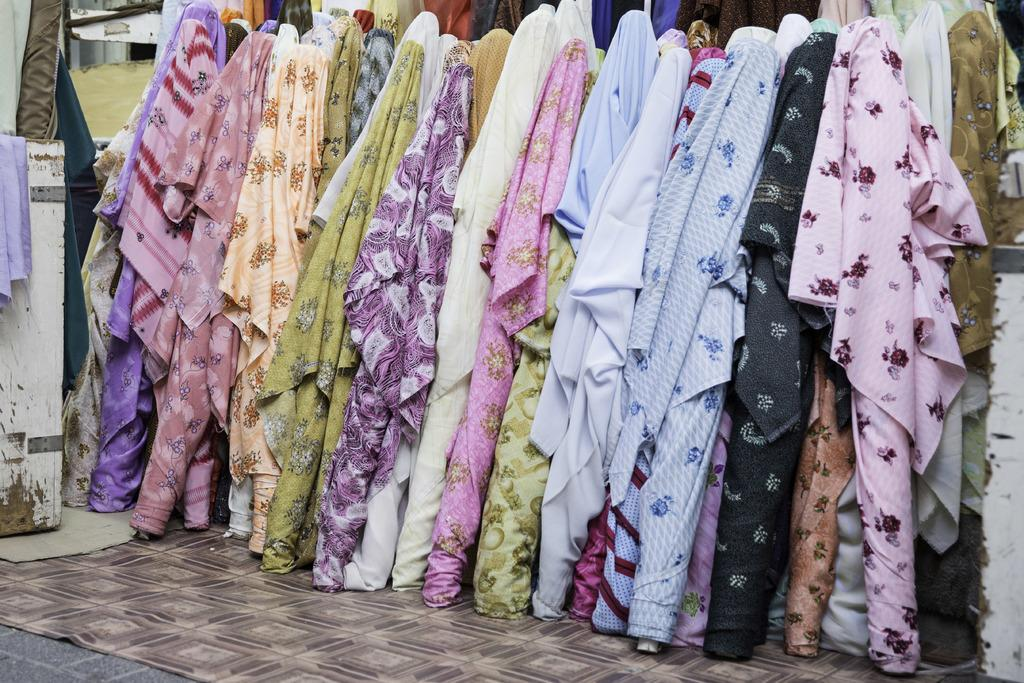What type of items are visible in the image? There are clothes in multi colors in the image. What is the color of the background wall in the image? The background wall is white in color. How many girls are present in the image? There is no reference to any girls in the image, as it only features clothes and a white background wall. What type of brain is visible in the image? There is no brain present in the image; it only features clothes and a white background wall. 